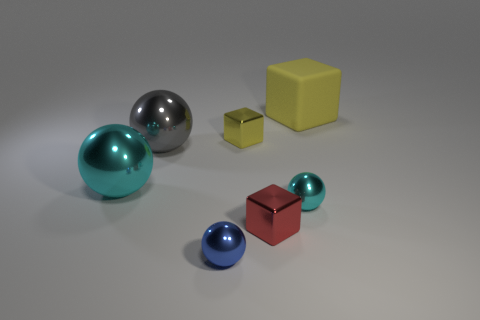Subtract all big gray metallic spheres. How many spheres are left? 3 Add 1 large purple matte spheres. How many objects exist? 8 Subtract all gray balls. How many yellow cubes are left? 2 Subtract all balls. How many objects are left? 3 Subtract all gray balls. How many balls are left? 3 Subtract 2 cubes. How many cubes are left? 1 Subtract 0 green cubes. How many objects are left? 7 Subtract all purple cubes. Subtract all yellow balls. How many cubes are left? 3 Subtract all tiny shiny spheres. Subtract all big red matte cubes. How many objects are left? 5 Add 5 tiny yellow metal objects. How many tiny yellow metal objects are left? 6 